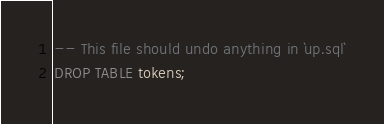Convert code to text. <code><loc_0><loc_0><loc_500><loc_500><_SQL_>-- This file should undo anything in `up.sql`
DROP TABLE tokens;</code> 